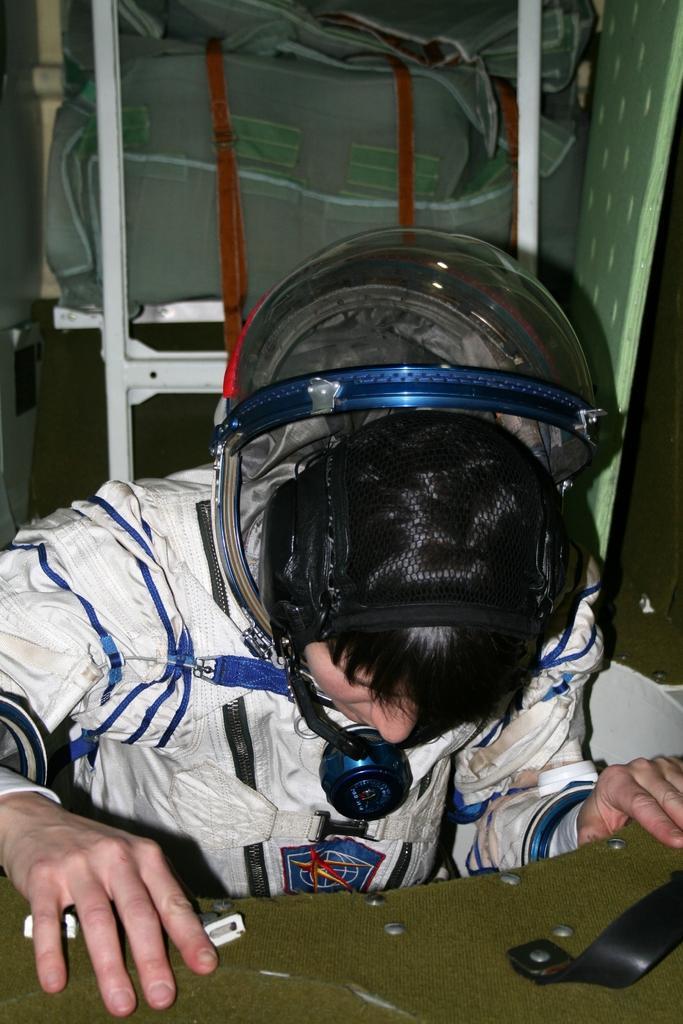Please provide a concise description of this image. In the image there is a man with space suit and helmet on his head. In front of him there is a green surface. Behind him there are white poles with bags in it. 